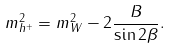<formula> <loc_0><loc_0><loc_500><loc_500>m ^ { 2 } _ { h ^ { + } } = m ^ { 2 } _ { W } - 2 \frac { B } { \sin 2 \beta } .</formula> 